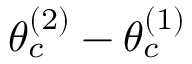Convert formula to latex. <formula><loc_0><loc_0><loc_500><loc_500>\theta _ { c } ^ { ( 2 ) } - \theta _ { c } ^ { ( 1 ) }</formula> 